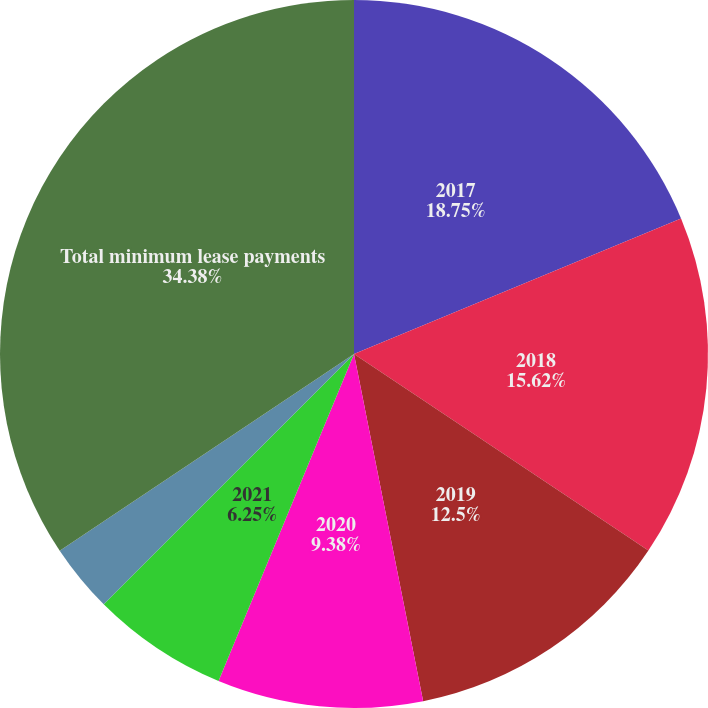<chart> <loc_0><loc_0><loc_500><loc_500><pie_chart><fcel>2017<fcel>2018<fcel>2019<fcel>2020<fcel>2021<fcel>Thereafter<fcel>Total minimum lease payments<nl><fcel>18.75%<fcel>15.62%<fcel>12.5%<fcel>9.38%<fcel>6.25%<fcel>3.12%<fcel>34.38%<nl></chart> 